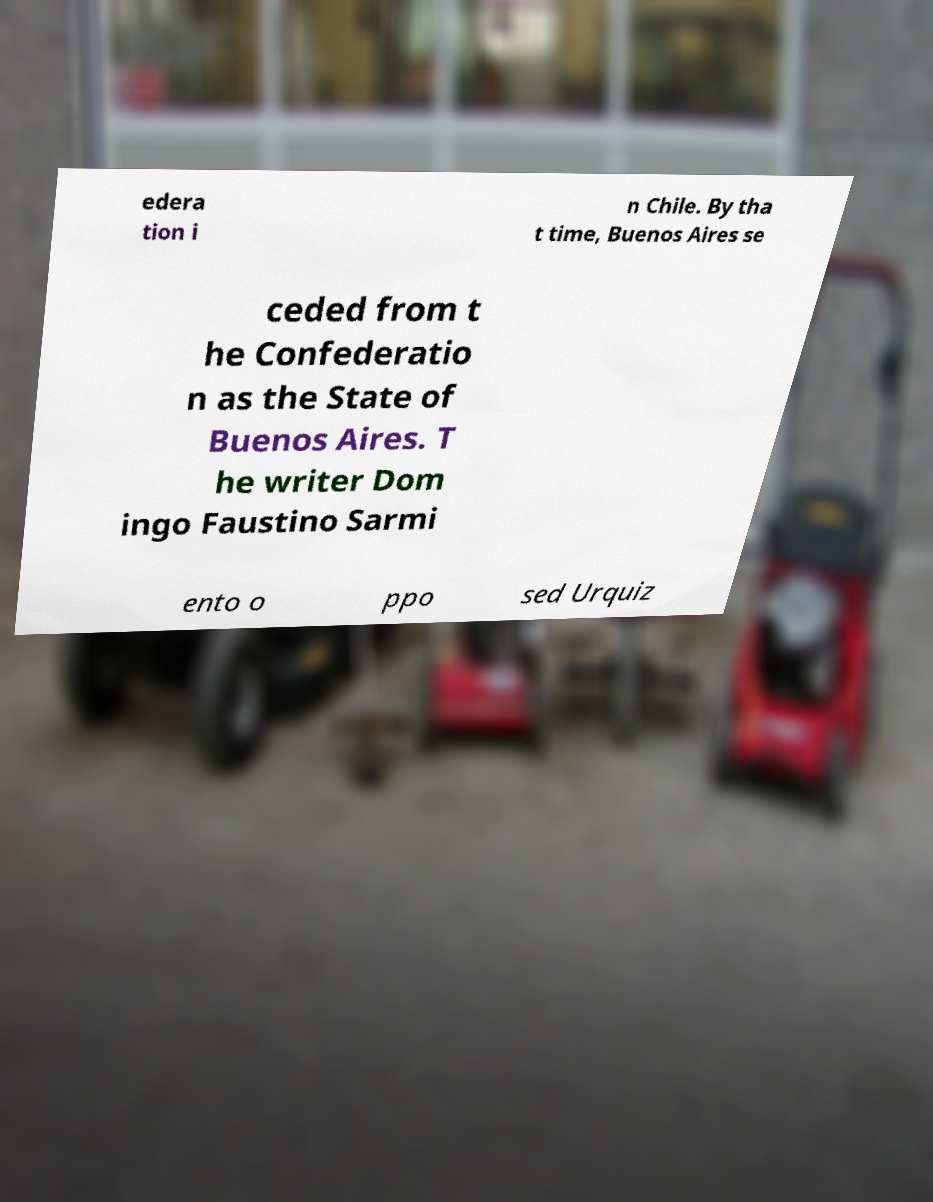Can you read and provide the text displayed in the image?This photo seems to have some interesting text. Can you extract and type it out for me? edera tion i n Chile. By tha t time, Buenos Aires se ceded from t he Confederatio n as the State of Buenos Aires. T he writer Dom ingo Faustino Sarmi ento o ppo sed Urquiz 